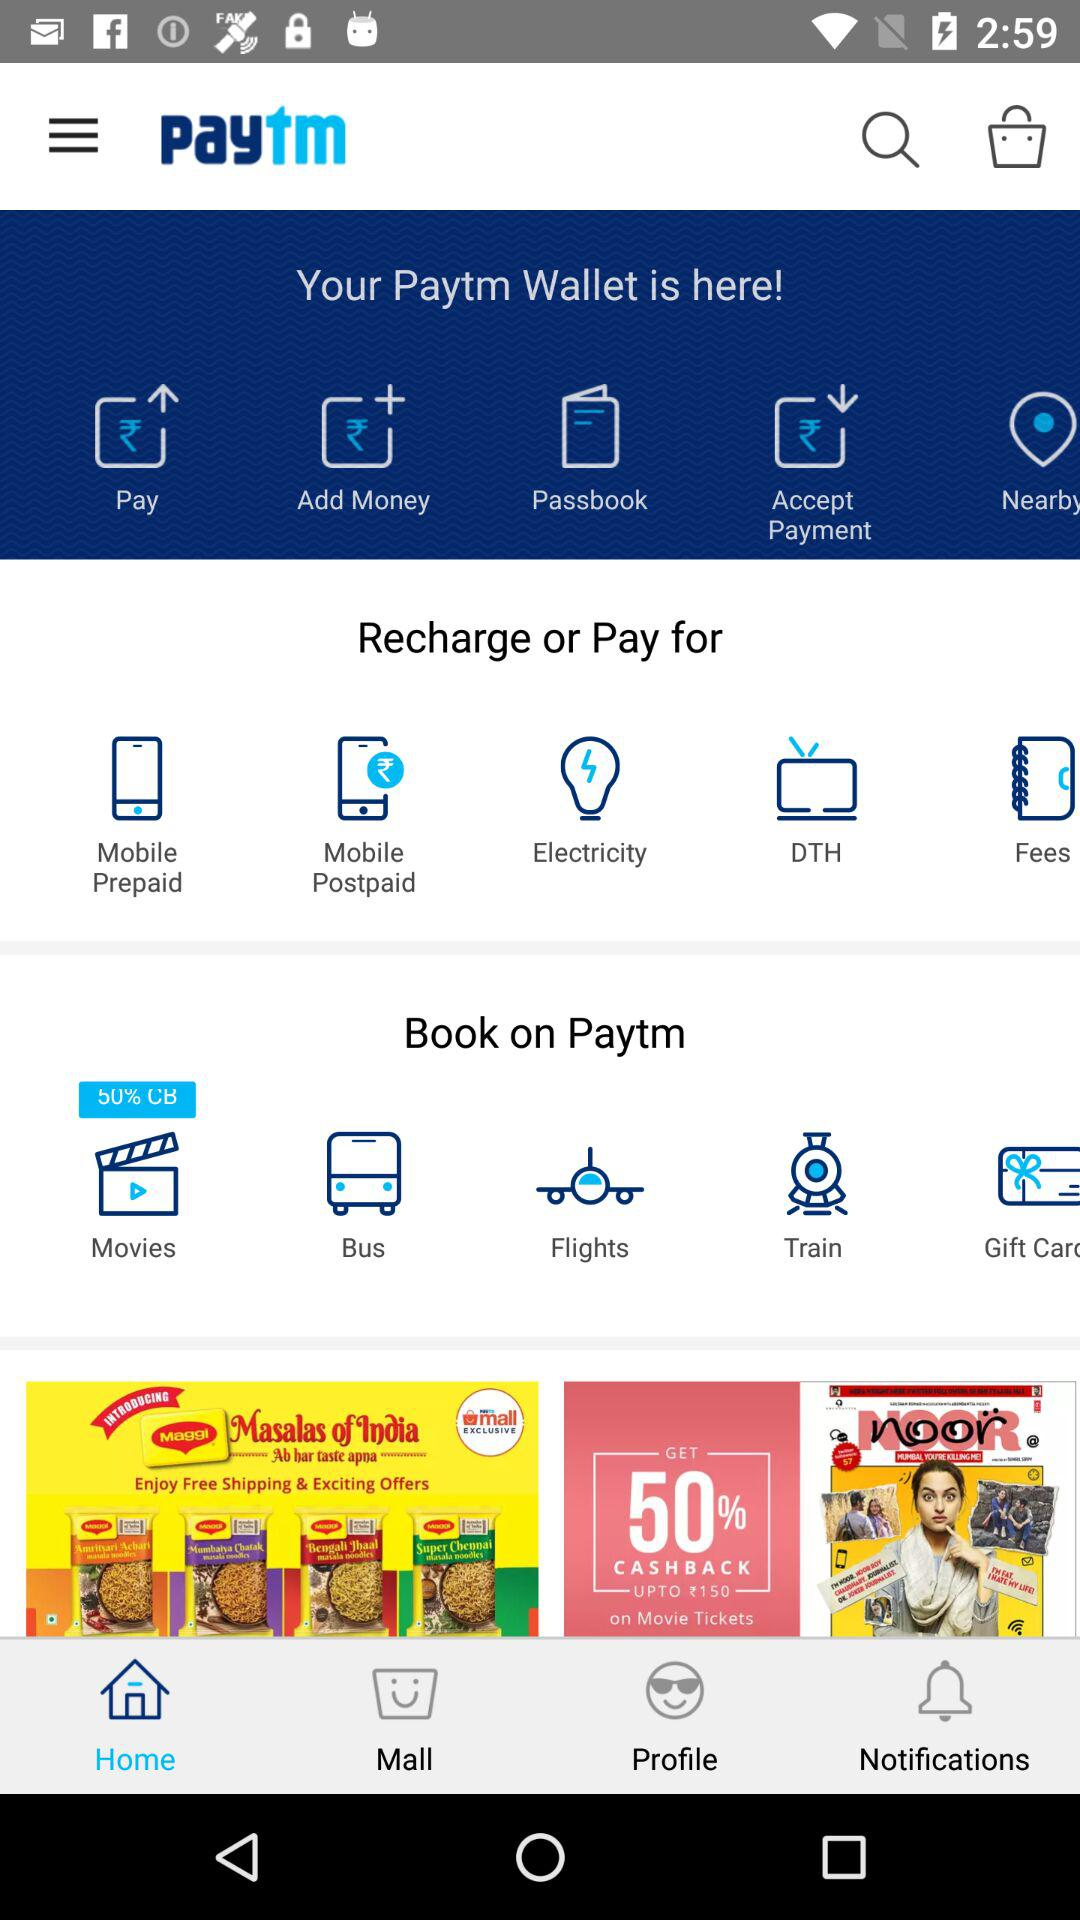How much is the cashback on movie tickets? On movie tickets, there is a 50% cashback up to ₹150. 